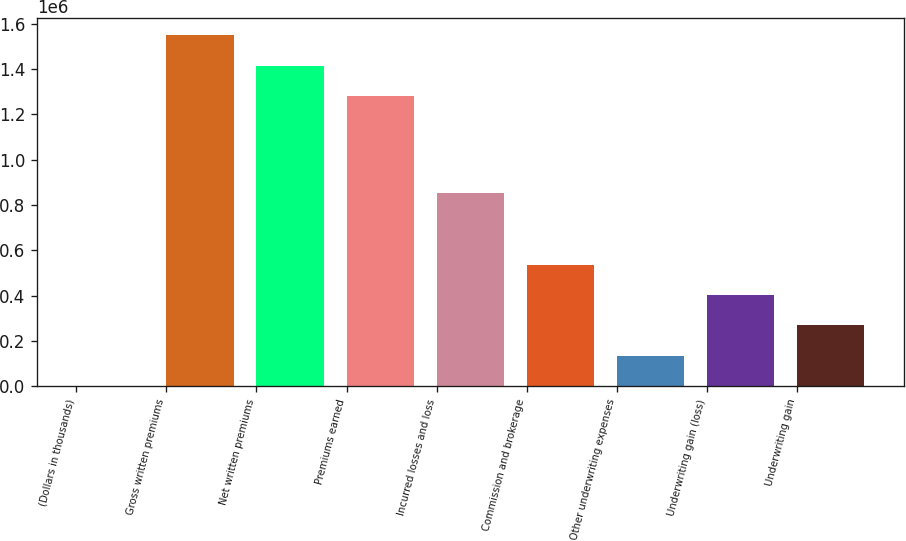Convert chart to OTSL. <chart><loc_0><loc_0><loc_500><loc_500><bar_chart><fcel>(Dollars in thousands)<fcel>Gross written premiums<fcel>Net written premiums<fcel>Premiums earned<fcel>Incurred losses and loss<fcel>Commission and brokerage<fcel>Other underwriting expenses<fcel>Underwriting gain (loss)<fcel>Underwriting gain<nl><fcel>2006<fcel>1.548e+06<fcel>1.41453e+06<fcel>1.28106e+06<fcel>851172<fcel>535895<fcel>135478<fcel>402423<fcel>268950<nl></chart> 